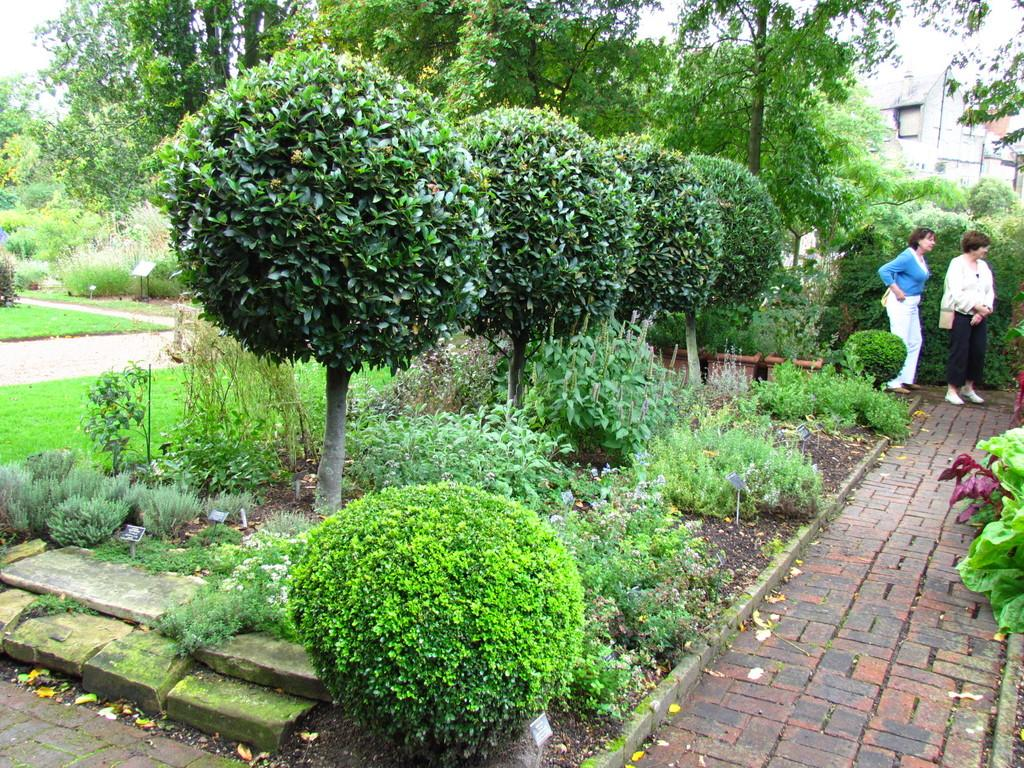Where was the image taken? The image was clicked outside. What can be seen in the middle of the image? There are bushes and trees in the middle of the image. Who is present on the right side of the image? There are two women on the right side of the image. What structure is visible on the right side of the image? There is a building on the right side of the image. What type of match is being played in the image? There is no match or any sporting event visible in the image. How low is the stage in the image? There is no stage present in the image. 